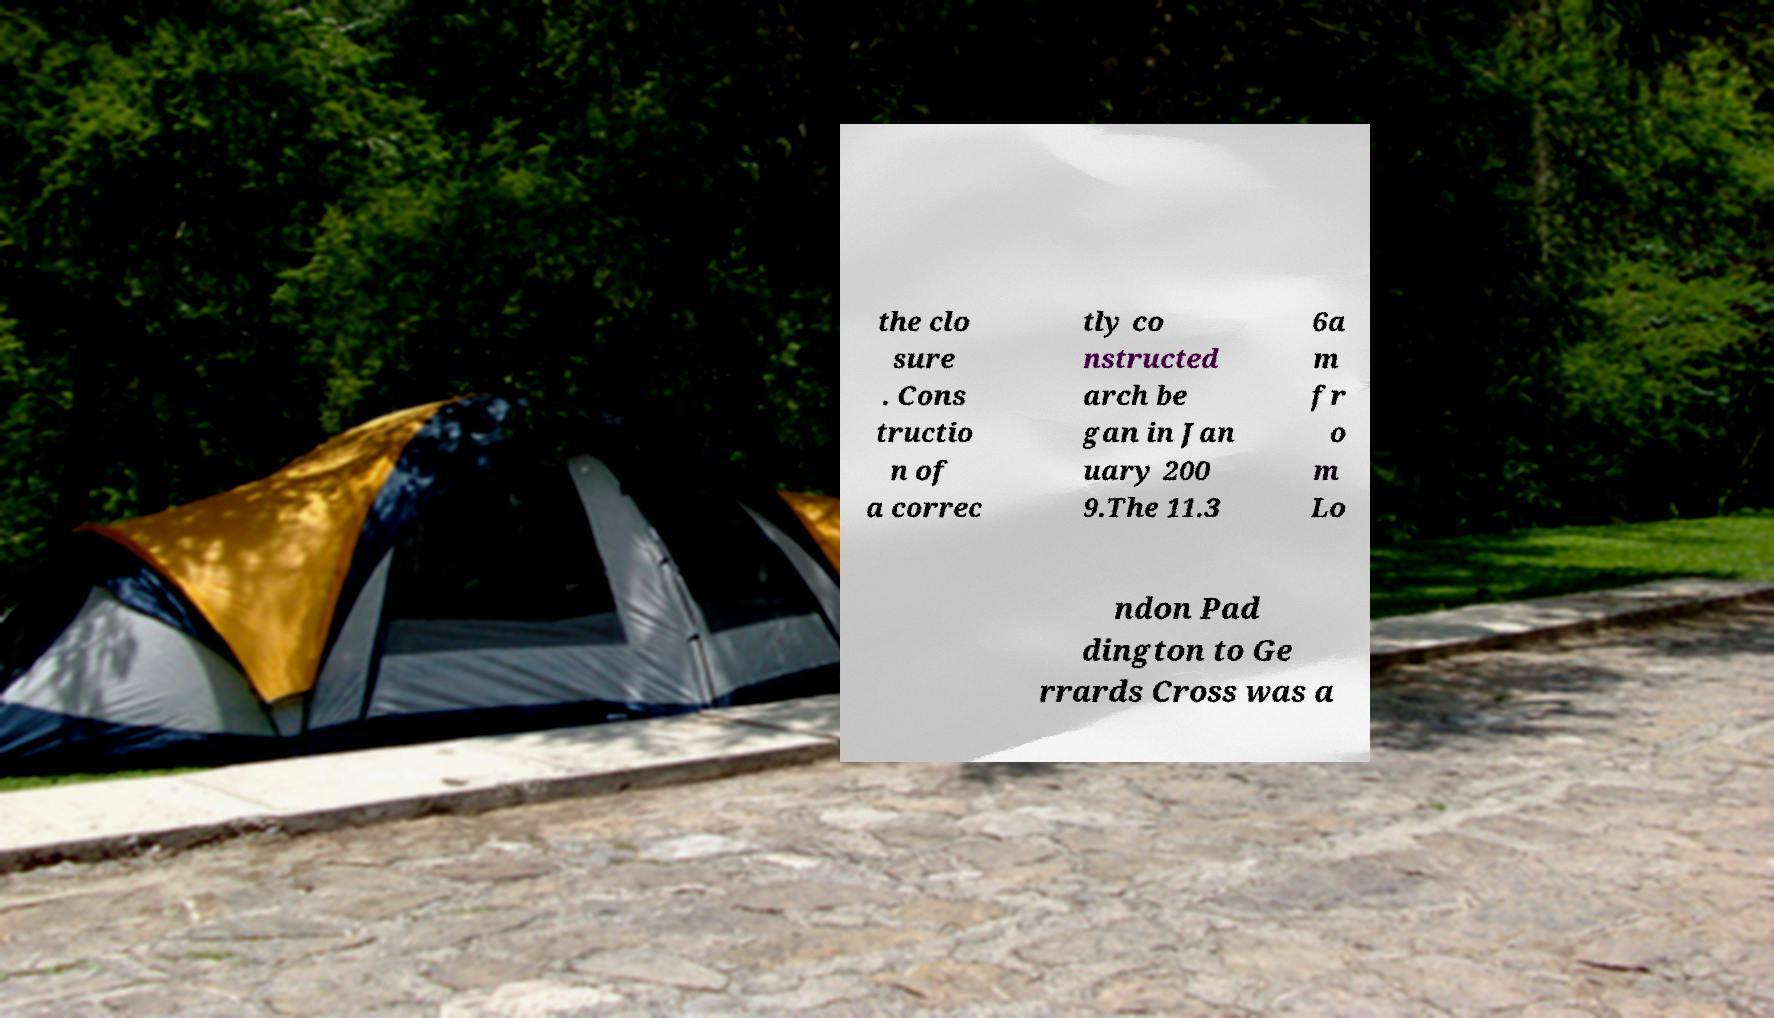What messages or text are displayed in this image? I need them in a readable, typed format. the clo sure . Cons tructio n of a correc tly co nstructed arch be gan in Jan uary 200 9.The 11.3 6a m fr o m Lo ndon Pad dington to Ge rrards Cross was a 